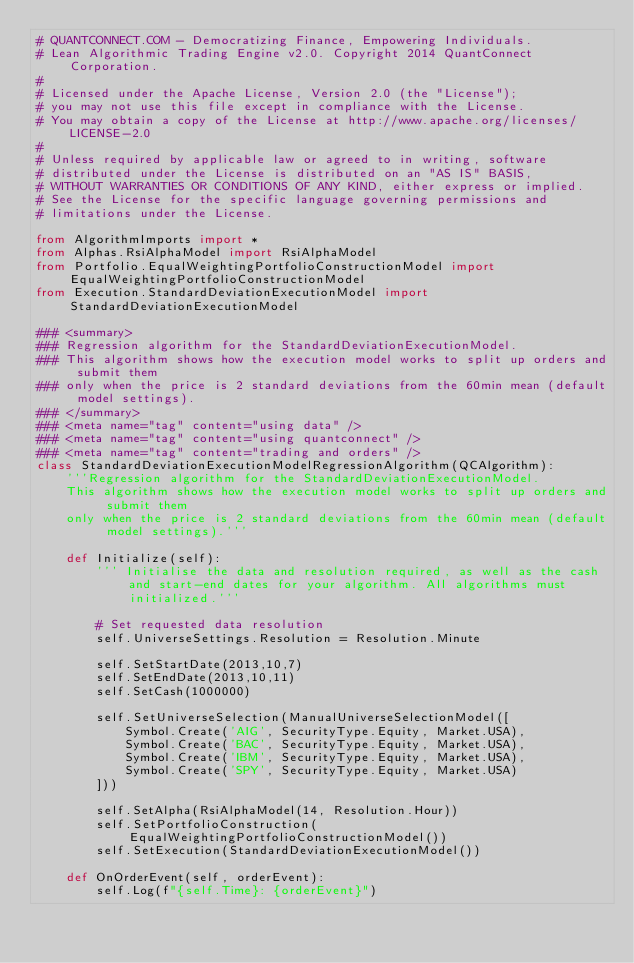Convert code to text. <code><loc_0><loc_0><loc_500><loc_500><_Python_># QUANTCONNECT.COM - Democratizing Finance, Empowering Individuals.
# Lean Algorithmic Trading Engine v2.0. Copyright 2014 QuantConnect Corporation.
#
# Licensed under the Apache License, Version 2.0 (the "License");
# you may not use this file except in compliance with the License.
# You may obtain a copy of the License at http://www.apache.org/licenses/LICENSE-2.0
#
# Unless required by applicable law or agreed to in writing, software
# distributed under the License is distributed on an "AS IS" BASIS,
# WITHOUT WARRANTIES OR CONDITIONS OF ANY KIND, either express or implied.
# See the License for the specific language governing permissions and
# limitations under the License.

from AlgorithmImports import *
from Alphas.RsiAlphaModel import RsiAlphaModel
from Portfolio.EqualWeightingPortfolioConstructionModel import EqualWeightingPortfolioConstructionModel
from Execution.StandardDeviationExecutionModel import StandardDeviationExecutionModel

### <summary>
### Regression algorithm for the StandardDeviationExecutionModel.
### This algorithm shows how the execution model works to split up orders and submit them
### only when the price is 2 standard deviations from the 60min mean (default model settings).
### </summary>
### <meta name="tag" content="using data" />
### <meta name="tag" content="using quantconnect" />
### <meta name="tag" content="trading and orders" />
class StandardDeviationExecutionModelRegressionAlgorithm(QCAlgorithm):
    '''Regression algorithm for the StandardDeviationExecutionModel.
    This algorithm shows how the execution model works to split up orders and submit them
    only when the price is 2 standard deviations from the 60min mean (default model settings).'''

    def Initialize(self):
        ''' Initialise the data and resolution required, as well as the cash and start-end dates for your algorithm. All algorithms must initialized.'''

        # Set requested data resolution
        self.UniverseSettings.Resolution = Resolution.Minute

        self.SetStartDate(2013,10,7)
        self.SetEndDate(2013,10,11)
        self.SetCash(1000000)

        self.SetUniverseSelection(ManualUniverseSelectionModel([
            Symbol.Create('AIG', SecurityType.Equity, Market.USA),
            Symbol.Create('BAC', SecurityType.Equity, Market.USA),
            Symbol.Create('IBM', SecurityType.Equity, Market.USA),
            Symbol.Create('SPY', SecurityType.Equity, Market.USA)
        ]))

        self.SetAlpha(RsiAlphaModel(14, Resolution.Hour))
        self.SetPortfolioConstruction(EqualWeightingPortfolioConstructionModel())
        self.SetExecution(StandardDeviationExecutionModel())

    def OnOrderEvent(self, orderEvent):
        self.Log(f"{self.Time}: {orderEvent}")
</code> 